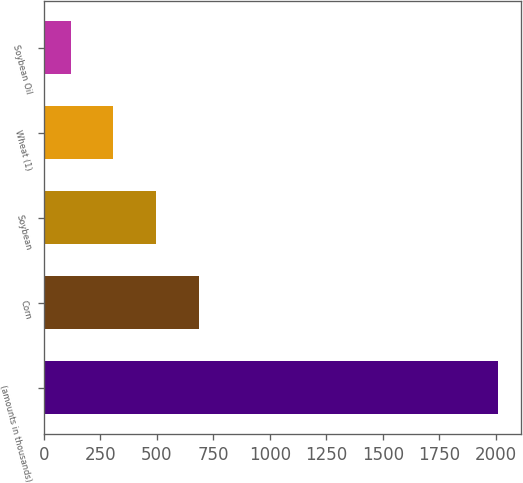Convert chart. <chart><loc_0><loc_0><loc_500><loc_500><bar_chart><fcel>(amounts in thousands)<fcel>Corn<fcel>Soybean<fcel>Wheat (1)<fcel>Soybean Oil<nl><fcel>2012<fcel>686.2<fcel>496.8<fcel>307.4<fcel>118<nl></chart> 